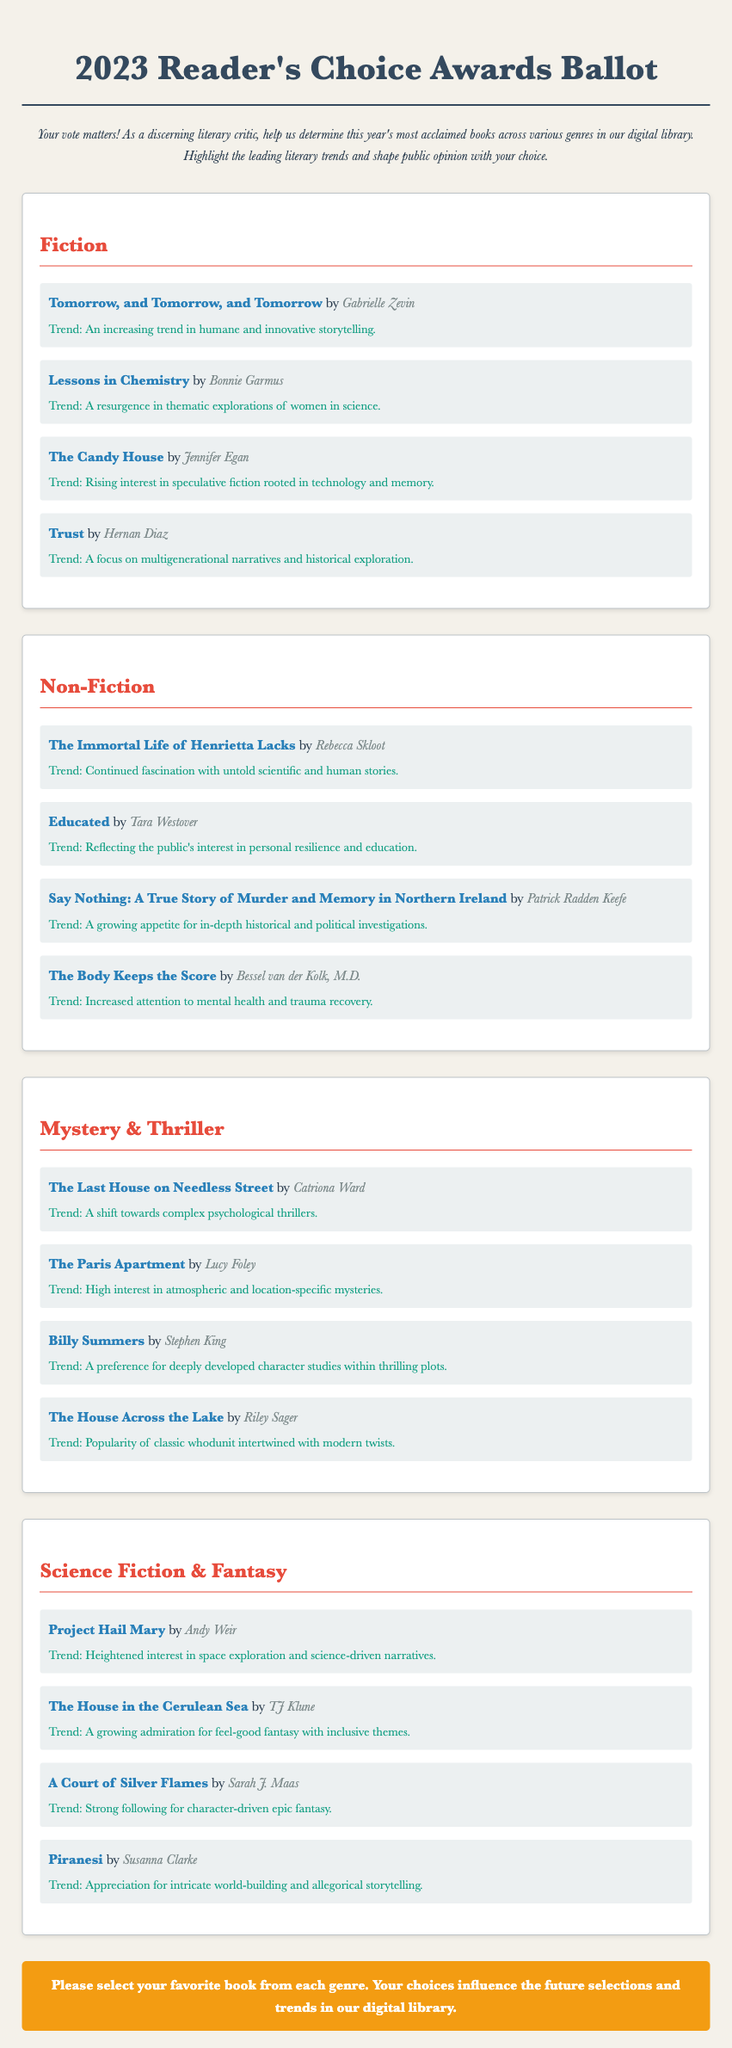What is the title of the Fiction book by Gabrielle Zevin? The title is listed first among the Fiction selections.
Answer: Tomorrow, and Tomorrow, and Tomorrow Who authored "Educated"? The author of "Educated" is mentioned under the Non-Fiction section.
Answer: Tara Westover What genre does "The Last House on Needless Street" belong to? The genre is specified in the Mystery & Thriller section.
Answer: Mystery & Thriller Which book reflects a resurgence in thematic explorations of women in science? The specific trend related to women in science is discussed in the Fiction section.
Answer: Lessons in Chemistry How many books are listed in the Science Fiction & Fantasy genre? The number of books can be counted from that specific section of the document.
Answer: Four What trend is associated with "The Body Keeps the Score"? The trend is provided alongside the Non-Fiction selection.
Answer: Increased attention to mental health and trauma recovery Which author wrote "Piranesi"? The author of "Piranesi" is included in the Science Fiction & Fantasy section.
Answer: Susanna Clarke What is the color of the background mentioned in the document? The document specifies the background color used in its design.
Answer: #f4f1ea 